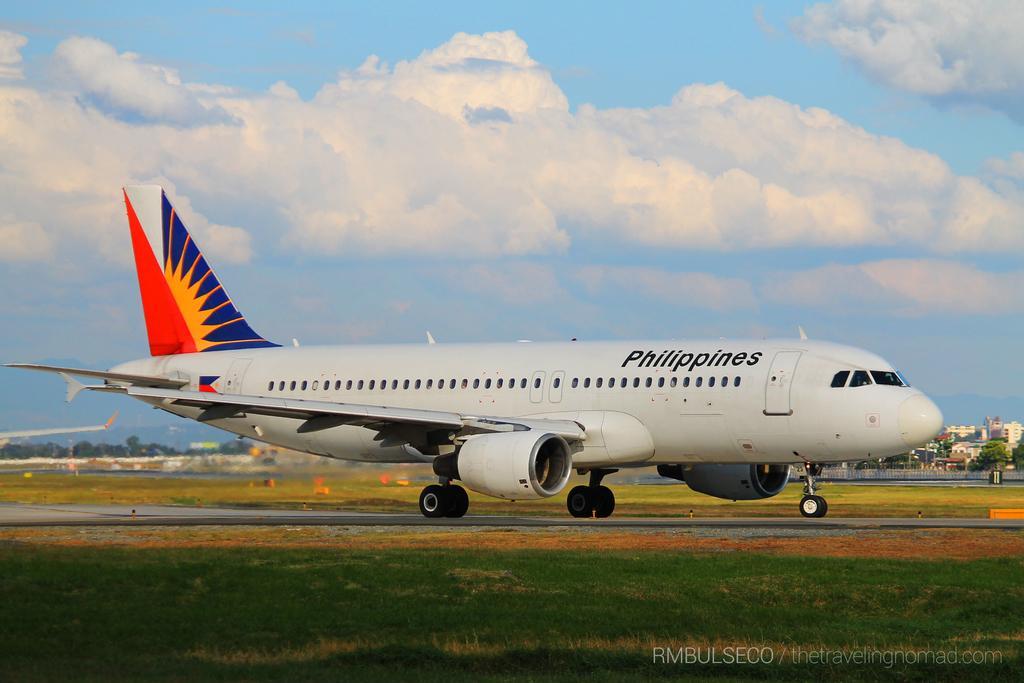Describe this image in one or two sentences. In this image we can see an airplane on the ground, there are some buildings, grass, trees, fence and some other objects on the ground, in the background we can see the sky with clouds. 